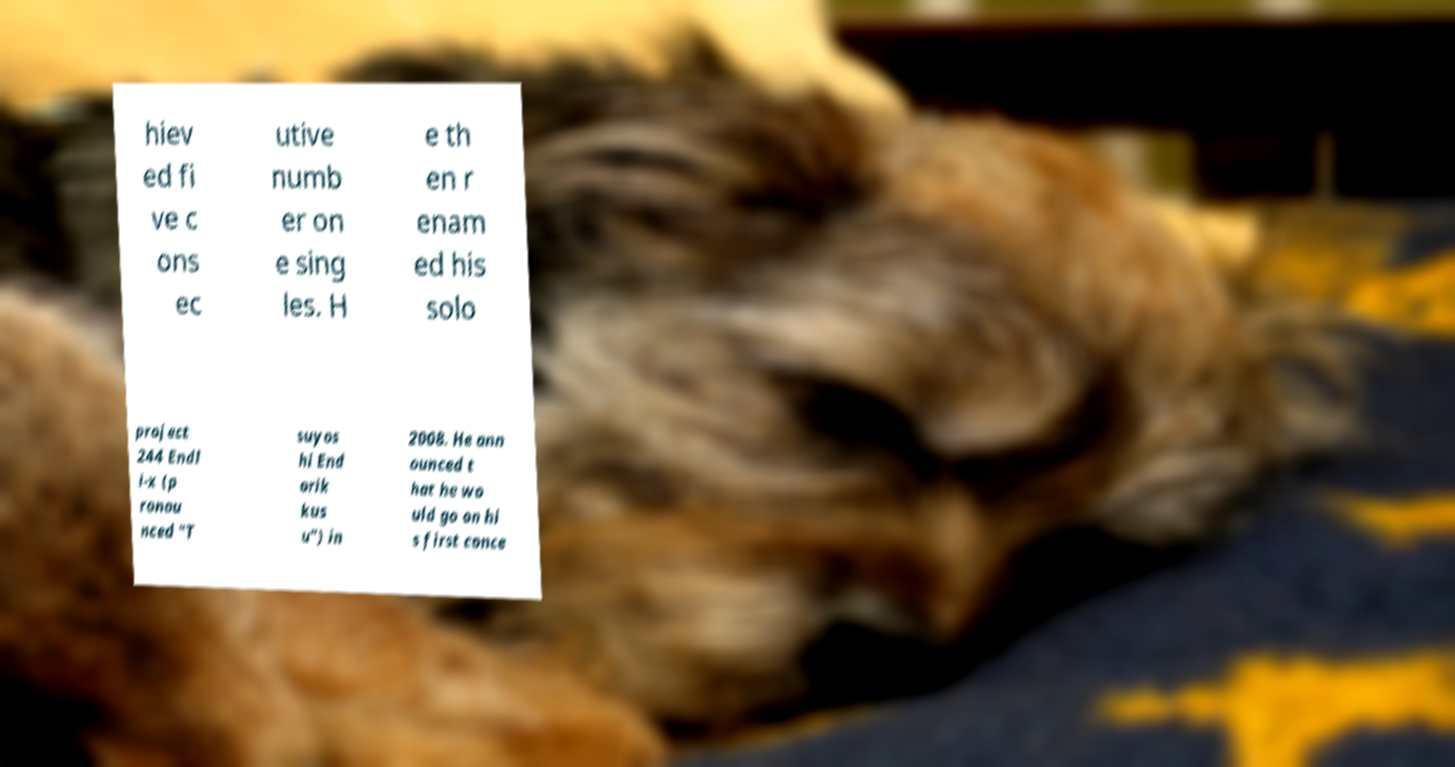Please identify and transcribe the text found in this image. hiev ed fi ve c ons ec utive numb er on e sing les. H e th en r enam ed his solo project 244 Endl i-x (p ronou nced "T suyos hi End orik kus u") in 2008. He ann ounced t hat he wo uld go on hi s first conce 